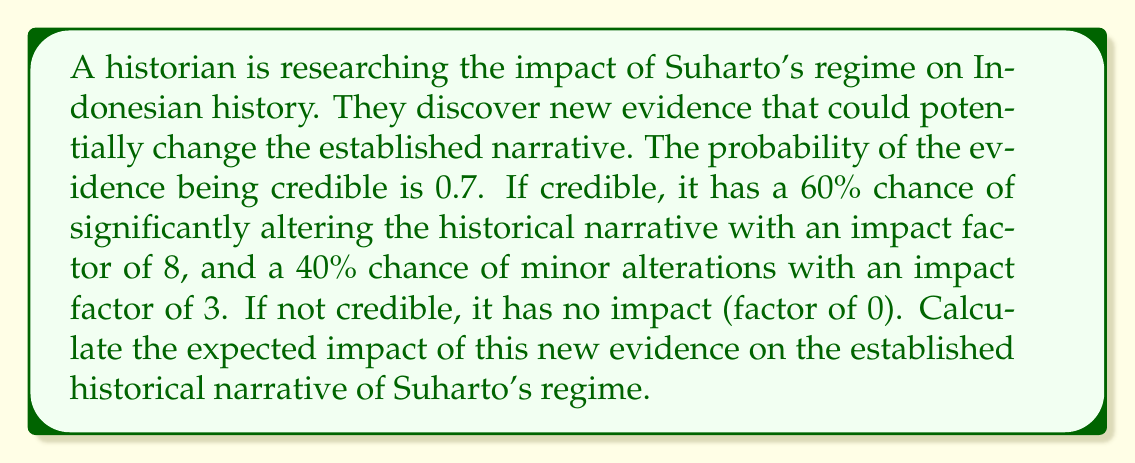Give your solution to this math problem. Let's approach this step-by-step:

1) First, we need to identify the possible outcomes and their probabilities:
   - Credible and significant: $0.7 \times 0.6 = 0.42$
   - Credible and minor: $0.7 \times 0.4 = 0.28$
   - Not credible: $1 - 0.7 = 0.3$

2) Now, let's calculate the impact for each outcome:
   - Credible and significant: impact factor of 8
   - Credible and minor: impact factor of 3
   - Not credible: impact factor of 0

3) The expected value is calculated by multiplying each outcome's probability by its impact and summing these products:

   $$E = (0.42 \times 8) + (0.28 \times 3) + (0.3 \times 0)$$

4) Let's compute:
   $$E = 3.36 + 0.84 + 0$$
   $$E = 4.2$$

Therefore, the expected impact of the new evidence on the established historical narrative of Suharto's regime is 4.2.
Answer: 4.2 